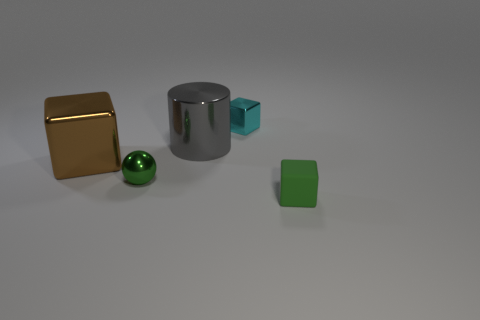Can you explain what the lighting reveals about the shapes? The lighting in the image casts soft shadows and highlights that help accentuate the three-dimensional forms of the objects. The golden cube reflects light evenly on its faces, indicating flat surfaces. The chrome cylinder reveals a graded reflection that emphasizes its cylindrical shape, and the green ball shows a uniform highlight and shadow suggesting a smooth, spherical form. The green cube receives a softer light, suggesting a less reflective surface. 